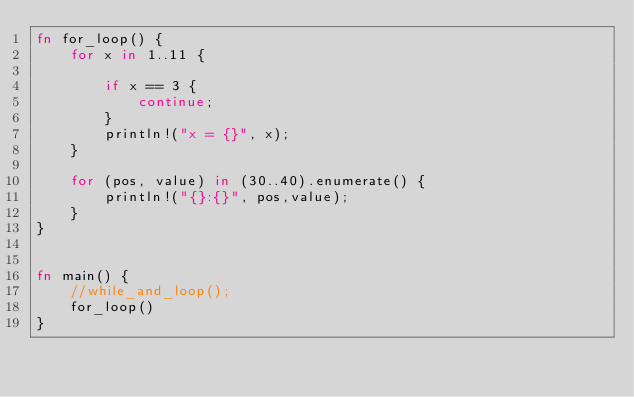Convert code to text. <code><loc_0><loc_0><loc_500><loc_500><_Rust_>fn for_loop() {
    for x in 1..11 {

        if x == 3 {
            continue;
        }
        println!("x = {}", x);
    }

    for (pos, value) in (30..40).enumerate() {
        println!("{}:{}", pos,value);
    }
}


fn main() {
    //while_and_loop();
    for_loop()
}
</code> 